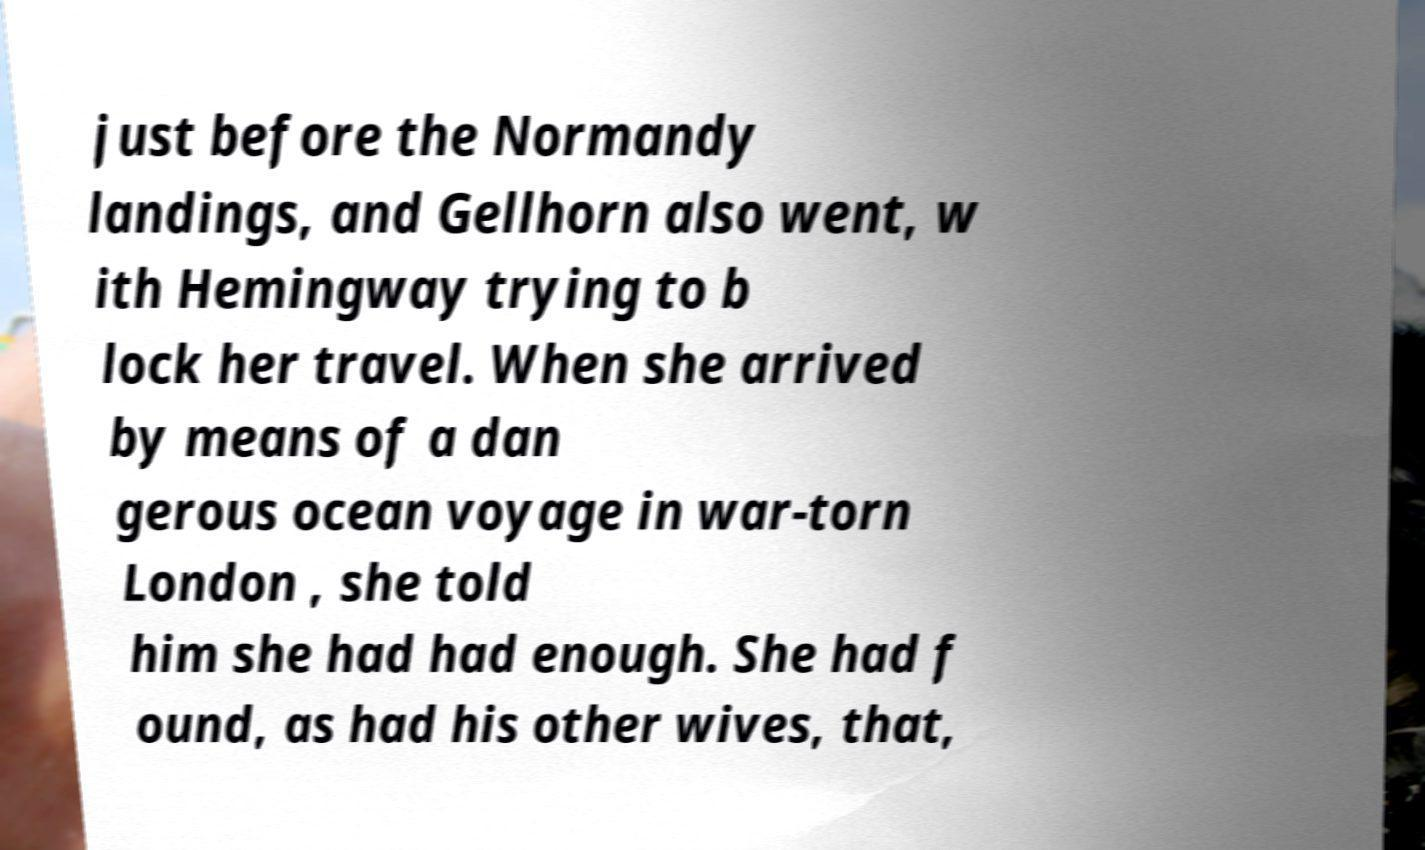For documentation purposes, I need the text within this image transcribed. Could you provide that? just before the Normandy landings, and Gellhorn also went, w ith Hemingway trying to b lock her travel. When she arrived by means of a dan gerous ocean voyage in war-torn London , she told him she had had enough. She had f ound, as had his other wives, that, 